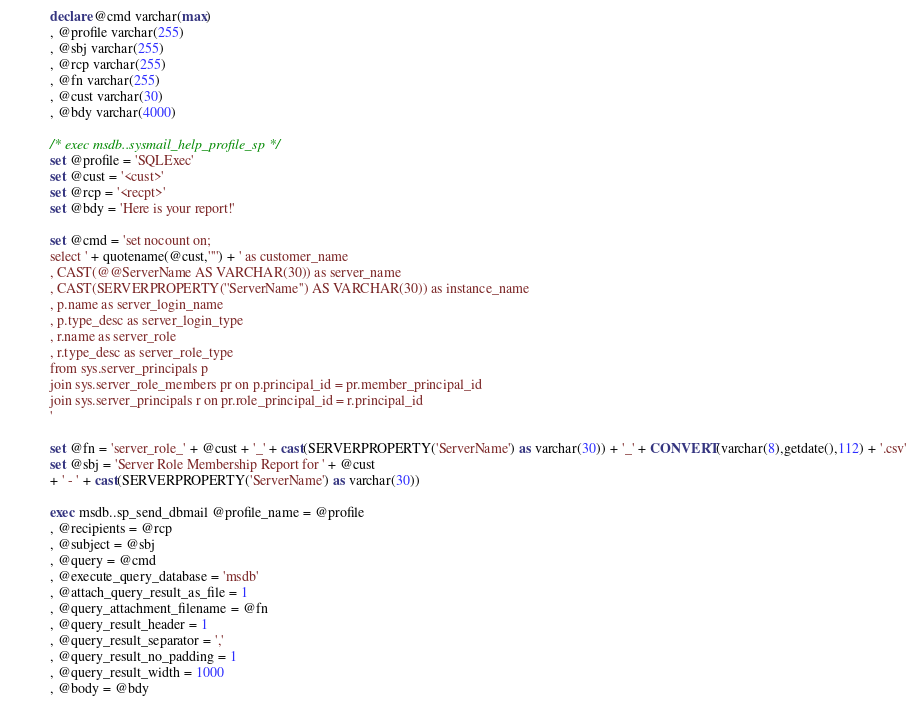<code> <loc_0><loc_0><loc_500><loc_500><_SQL_>
declare @cmd varchar(max) 
, @profile varchar(255)
, @sbj varchar(255)
, @rcp varchar(255)
, @fn varchar(255)
, @cust varchar(30)
, @bdy varchar(4000)

/* exec msdb..sysmail_help_profile_sp */
set @profile = 'SQLExec'
set @cust = '<cust>'
set @rcp = '<recpt>'
set @bdy = 'Here is your report!'

set @cmd = 'set nocount on;
select ' + quotename(@cust,'''') + ' as customer_name
, CAST(@@ServerName AS VARCHAR(30)) as server_name
, CAST(SERVERPROPERTY(''ServerName'') AS VARCHAR(30)) as instance_name
, p.name as server_login_name
, p.type_desc as server_login_type
, r.name as server_role
, r.type_desc as server_role_type
from sys.server_principals p
join sys.server_role_members pr on p.principal_id = pr.member_principal_id
join sys.server_principals r on pr.role_principal_id = r.principal_id
'

set @fn = 'server_role_' + @cust + '_' + cast(SERVERPROPERTY('ServerName') as varchar(30)) + '_' + CONVERT(varchar(8),getdate(),112) + '.csv'
set @sbj = 'Server Role Membership Report for ' + @cust 
+ ' - ' + cast(SERVERPROPERTY('ServerName') as varchar(30)) 

exec msdb..sp_send_dbmail @profile_name = @profile
, @recipients = @rcp
, @subject = @sbj
, @query = @cmd
, @execute_query_database = 'msdb'
, @attach_query_result_as_file = 1
, @query_attachment_filename = @fn
, @query_result_header = 1
, @query_result_separator = ','
, @query_result_no_padding = 1
, @query_result_width = 1000
, @body = @bdy


</code> 